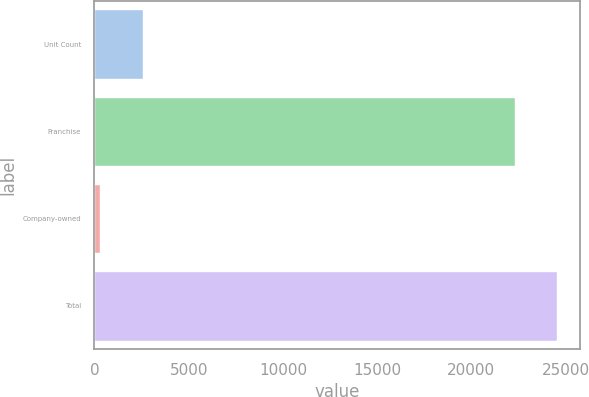Convert chart to OTSL. <chart><loc_0><loc_0><loc_500><loc_500><bar_chart><fcel>Unit Count<fcel>Franchise<fcel>Company-owned<fcel>Total<nl><fcel>2553.7<fcel>22297<fcel>324<fcel>24526.7<nl></chart> 